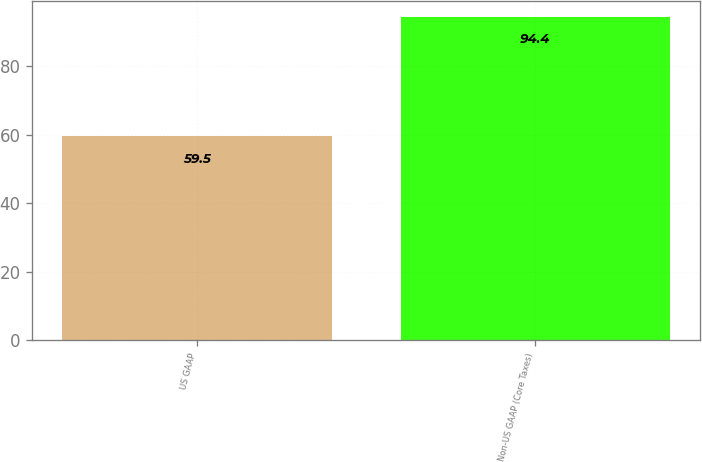<chart> <loc_0><loc_0><loc_500><loc_500><bar_chart><fcel>US GAAP<fcel>Non-US GAAP (Core Taxes)<nl><fcel>59.5<fcel>94.4<nl></chart> 